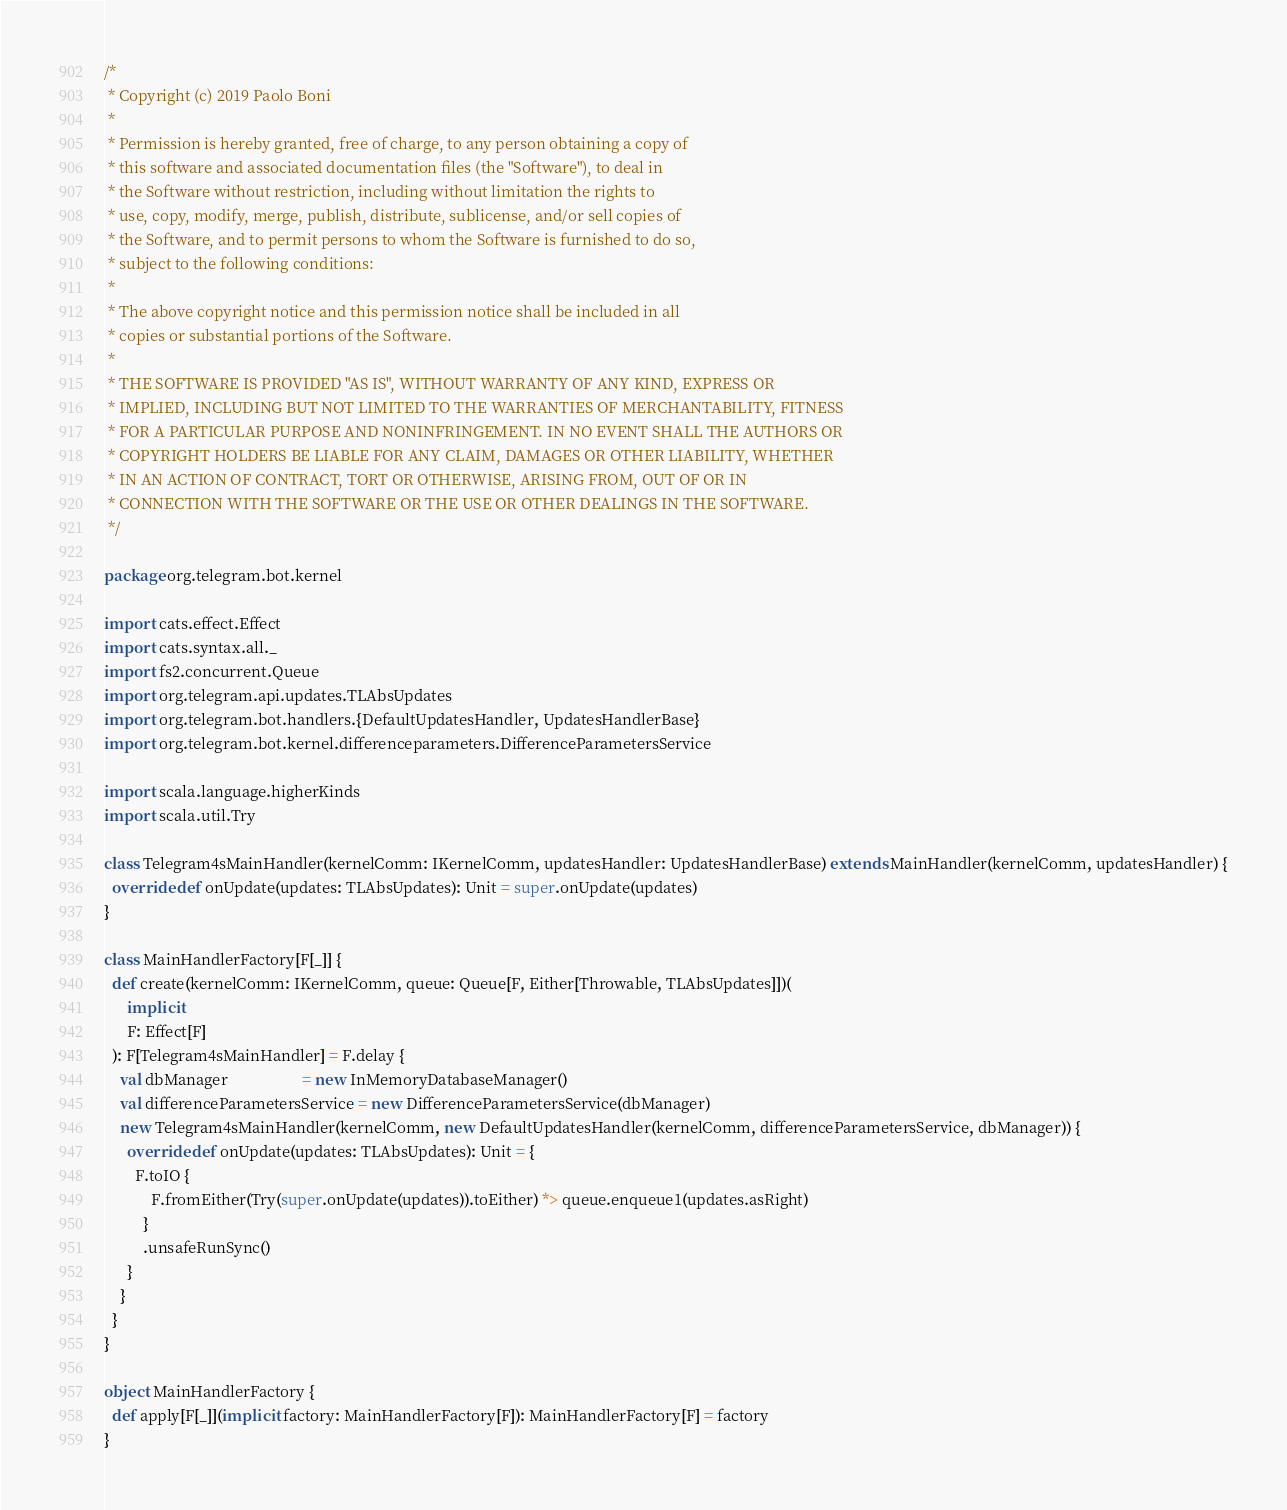<code> <loc_0><loc_0><loc_500><loc_500><_Scala_>/*
 * Copyright (c) 2019 Paolo Boni
 *
 * Permission is hereby granted, free of charge, to any person obtaining a copy of
 * this software and associated documentation files (the "Software"), to deal in
 * the Software without restriction, including without limitation the rights to
 * use, copy, modify, merge, publish, distribute, sublicense, and/or sell copies of
 * the Software, and to permit persons to whom the Software is furnished to do so,
 * subject to the following conditions:
 *
 * The above copyright notice and this permission notice shall be included in all
 * copies or substantial portions of the Software.
 *
 * THE SOFTWARE IS PROVIDED "AS IS", WITHOUT WARRANTY OF ANY KIND, EXPRESS OR
 * IMPLIED, INCLUDING BUT NOT LIMITED TO THE WARRANTIES OF MERCHANTABILITY, FITNESS
 * FOR A PARTICULAR PURPOSE AND NONINFRINGEMENT. IN NO EVENT SHALL THE AUTHORS OR
 * COPYRIGHT HOLDERS BE LIABLE FOR ANY CLAIM, DAMAGES OR OTHER LIABILITY, WHETHER
 * IN AN ACTION OF CONTRACT, TORT OR OTHERWISE, ARISING FROM, OUT OF OR IN
 * CONNECTION WITH THE SOFTWARE OR THE USE OR OTHER DEALINGS IN THE SOFTWARE.
 */

package org.telegram.bot.kernel

import cats.effect.Effect
import cats.syntax.all._
import fs2.concurrent.Queue
import org.telegram.api.updates.TLAbsUpdates
import org.telegram.bot.handlers.{DefaultUpdatesHandler, UpdatesHandlerBase}
import org.telegram.bot.kernel.differenceparameters.DifferenceParametersService

import scala.language.higherKinds
import scala.util.Try

class Telegram4sMainHandler(kernelComm: IKernelComm, updatesHandler: UpdatesHandlerBase) extends MainHandler(kernelComm, updatesHandler) {
  override def onUpdate(updates: TLAbsUpdates): Unit = super.onUpdate(updates)
}

class MainHandlerFactory[F[_]] {
  def create(kernelComm: IKernelComm, queue: Queue[F, Either[Throwable, TLAbsUpdates]])(
      implicit
      F: Effect[F]
  ): F[Telegram4sMainHandler] = F.delay {
    val dbManager                   = new InMemoryDatabaseManager()
    val differenceParametersService = new DifferenceParametersService(dbManager)
    new Telegram4sMainHandler(kernelComm, new DefaultUpdatesHandler(kernelComm, differenceParametersService, dbManager)) {
      override def onUpdate(updates: TLAbsUpdates): Unit = {
        F.toIO {
            F.fromEither(Try(super.onUpdate(updates)).toEither) *> queue.enqueue1(updates.asRight)
          }
          .unsafeRunSync()
      }
    }
  }
}

object MainHandlerFactory {
  def apply[F[_]](implicit factory: MainHandlerFactory[F]): MainHandlerFactory[F] = factory
}
</code> 